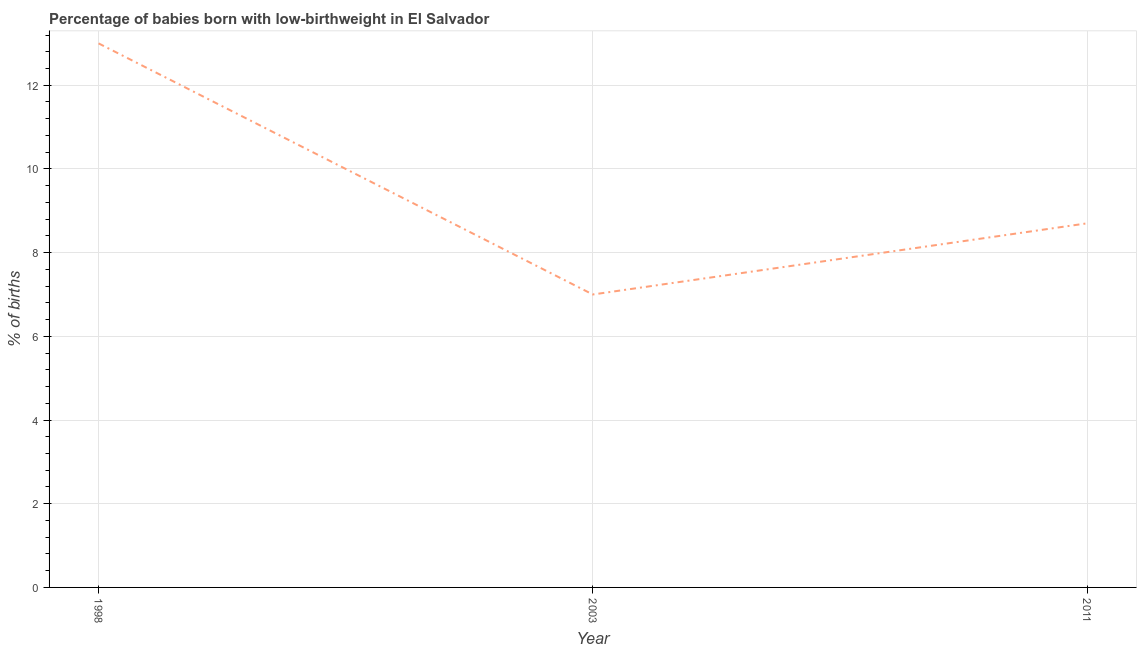What is the percentage of babies who were born with low-birthweight in 2011?
Ensure brevity in your answer.  8.7. Across all years, what is the minimum percentage of babies who were born with low-birthweight?
Your answer should be very brief. 7. In which year was the percentage of babies who were born with low-birthweight maximum?
Keep it short and to the point. 1998. What is the sum of the percentage of babies who were born with low-birthweight?
Offer a very short reply. 28.7. What is the difference between the percentage of babies who were born with low-birthweight in 1998 and 2003?
Give a very brief answer. 6. What is the average percentage of babies who were born with low-birthweight per year?
Ensure brevity in your answer.  9.57. In how many years, is the percentage of babies who were born with low-birthweight greater than 12.8 %?
Offer a terse response. 1. Do a majority of the years between 1998 and 2003 (inclusive) have percentage of babies who were born with low-birthweight greater than 3.6 %?
Your answer should be compact. Yes. What is the ratio of the percentage of babies who were born with low-birthweight in 1998 to that in 2003?
Provide a succinct answer. 1.86. Is the percentage of babies who were born with low-birthweight in 1998 less than that in 2003?
Your answer should be compact. No. What is the difference between the highest and the second highest percentage of babies who were born with low-birthweight?
Provide a short and direct response. 4.3. Is the sum of the percentage of babies who were born with low-birthweight in 2003 and 2011 greater than the maximum percentage of babies who were born with low-birthweight across all years?
Offer a very short reply. Yes. In how many years, is the percentage of babies who were born with low-birthweight greater than the average percentage of babies who were born with low-birthweight taken over all years?
Give a very brief answer. 1. How many lines are there?
Your response must be concise. 1. How many years are there in the graph?
Ensure brevity in your answer.  3. Does the graph contain any zero values?
Offer a terse response. No. Does the graph contain grids?
Make the answer very short. Yes. What is the title of the graph?
Keep it short and to the point. Percentage of babies born with low-birthweight in El Salvador. What is the label or title of the X-axis?
Give a very brief answer. Year. What is the label or title of the Y-axis?
Offer a very short reply. % of births. What is the % of births in 1998?
Your response must be concise. 13. What is the % of births in 2011?
Your answer should be very brief. 8.7. What is the difference between the % of births in 1998 and 2003?
Provide a succinct answer. 6. What is the ratio of the % of births in 1998 to that in 2003?
Make the answer very short. 1.86. What is the ratio of the % of births in 1998 to that in 2011?
Make the answer very short. 1.49. What is the ratio of the % of births in 2003 to that in 2011?
Make the answer very short. 0.81. 